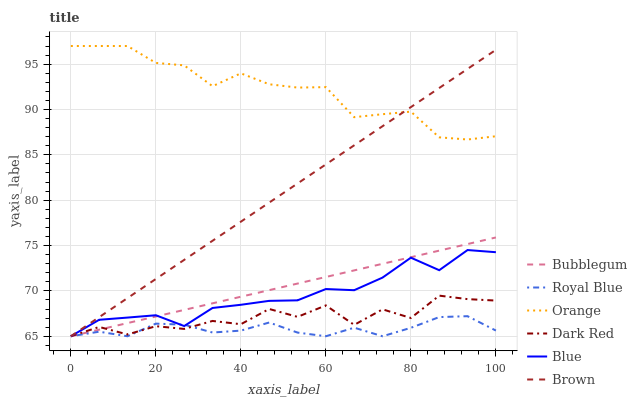Does Brown have the minimum area under the curve?
Answer yes or no. No. Does Brown have the maximum area under the curve?
Answer yes or no. No. Is Brown the smoothest?
Answer yes or no. No. Is Brown the roughest?
Answer yes or no. No. Does Orange have the lowest value?
Answer yes or no. No. Does Brown have the highest value?
Answer yes or no. No. Is Blue less than Orange?
Answer yes or no. Yes. Is Orange greater than Royal Blue?
Answer yes or no. Yes. Does Blue intersect Orange?
Answer yes or no. No. 